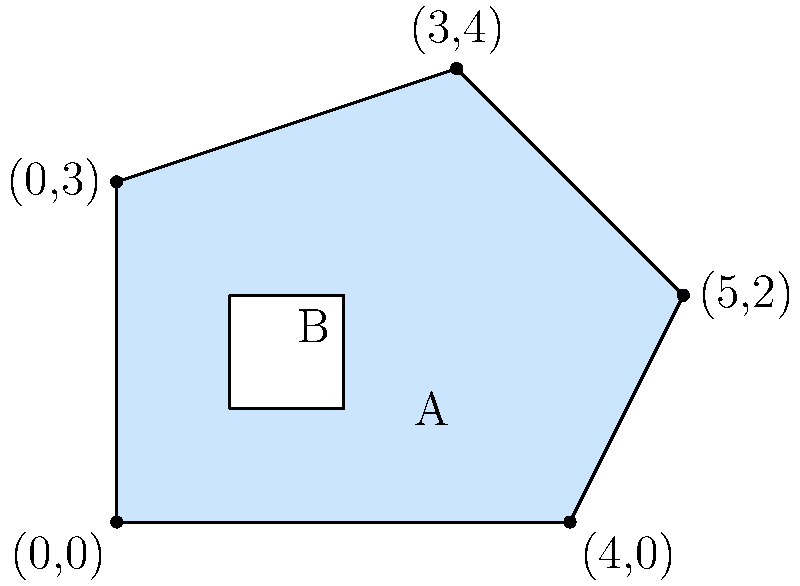The diagram represents a climate zone (blue area A) with an embedded glacier (white area B). The climate zone is an irregular pentagon with vertices at (0,0), (4,0), (5,2), (3,4), and (0,3). The glacier is a 1x1 square. Calculate the area of the climate zone excluding the glacier. Round your answer to two decimal places. To solve this problem, we'll follow these steps:

1. Calculate the area of the irregular pentagon (climate zone):
   We can divide the pentagon into three triangles:
   a) Triangle 1: (0,0), (4,0), (0,3)
   b) Triangle 2: (4,0), (5,2), (3,4)
   c) Triangle 3: (0,3), (4,0), (3,4)

   Area of a triangle = $\frac{1}{2}|x_1(y_2 - y_3) + x_2(y_3 - y_1) + x_3(y_1 - y_2)|$

   Triangle 1: $A_1 = \frac{1}{2}|0(0 - 3) + 4(3 - 0) + 0(0 - 0)| = 6$
   Triangle 2: $A_2 = \frac{1}{2}|4(2 - 4) + 5(4 - 0) + 3(0 - 2)| = 5$
   Triangle 3: $A_3 = \frac{1}{2}|0(0 - 4) + 4(4 - 3) + 3(3 - 0)| = 3$

   Total area of pentagon = $A_1 + A_2 + A_3 = 6 + 5 + 3 = 14$ square units

2. Calculate the area of the glacier:
   The glacier is a 1x1 square, so its area is 1 square unit.

3. Subtract the glacier area from the climate zone area:
   Climate zone area (excluding glacier) = $14 - 1 = 13$ square units

Therefore, the area of the climate zone excluding the glacier is 13 square units.
Answer: 13 square units 